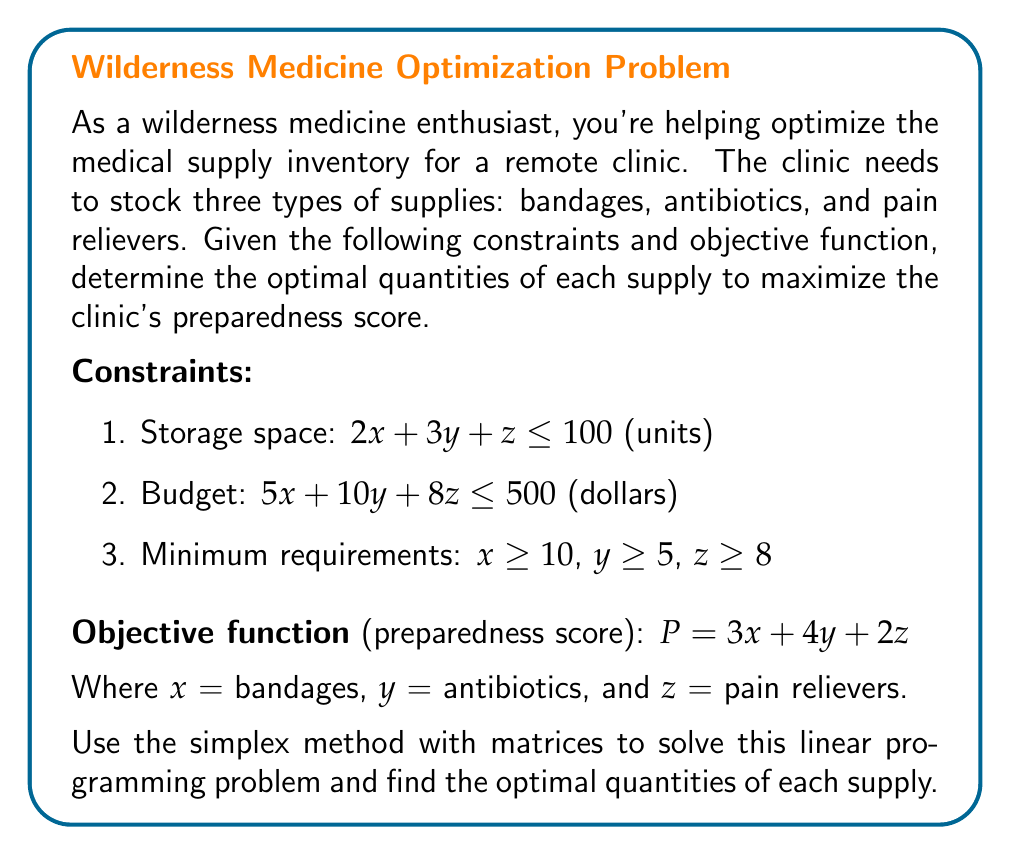Can you solve this math problem? To solve this problem using the simplex method with matrices, we'll follow these steps:

1. Convert the problem to standard form:
   Maximize $P = 3x + 4y + 2z$
   Subject to:
   $2x + 3y + z + s_1 = 100$
   $5x + 10y + 8z + s_2 = 500$
   $-x + s_3 = -10$
   $-y + s_4 = -5$
   $-z + s_5 = -8$
   $x, y, z, s_1, s_2, s_3, s_4, s_5 \geq 0$

2. Set up the initial tableau:

$$
\begin{array}{c|cccccccc|c}
 & x & y & z & s_1 & s_2 & s_3 & s_4 & s_5 & RHS \\
\hline
s_1 & 2 & 3 & 1 & 1 & 0 & 0 & 0 & 0 & 100 \\
s_2 & 5 & 10 & 8 & 0 & 1 & 0 & 0 & 0 & 500 \\
s_3 & -1 & 0 & 0 & 0 & 0 & 1 & 0 & 0 & -10 \\
s_4 & 0 & -1 & 0 & 0 & 0 & 0 & 1 & 0 & -5 \\
s_5 & 0 & 0 & -1 & 0 & 0 & 0 & 0 & 1 & -8 \\
\hline
P & -3 & -4 & -2 & 0 & 0 & 0 & 0 & 0 & 0
\end{array}
$$

3. Identify the pivot column (most negative in the objective row) and pivot row (smallest positive ratio of RHS to pivot column).

4. Perform row operations to make the pivot element 1 and all other elements in the pivot column 0.

5. Repeat steps 3-4 until there are no negative values in the objective row.

After several iterations, we reach the optimal solution:

$$
\begin{array}{c|cccccccc|c}
 & x & y & z & s_1 & s_2 & s_3 & s_4 & s_5 & RHS \\
\hline
x & 1 & 0 & 0 & 0.2 & 0 & 1 & 0 & 0 & 30 \\
y & 0 & 1 & 0 & 0.1 & 0 & 0 & 1 & 0 & 15 \\
z & 0 & 0 & 1 & 0.3 & 0 & 0 & 0 & 1 & 38 \\
s_2 & 0 & 0 & 0 & -2.9 & 1 & -5 & -10 & -8 & 10 \\
s_1 & 0 & 0 & 0 & 0.1 & 0 & -0.2 & -0.3 & -0.3 & 2 \\
\hline
P & 0 & 0 & 0 & 1.5 & 0 & 3 & 4 & 2 & 270
\end{array}
$$

The optimal solution is:
$x = 30$ (bandages)
$y = 15$ (antibiotics)
$z = 38$ (pain relievers)

The maximum preparedness score is 270.
Answer: $x = 30$, $y = 15$, $z = 38$; Max score = 270 